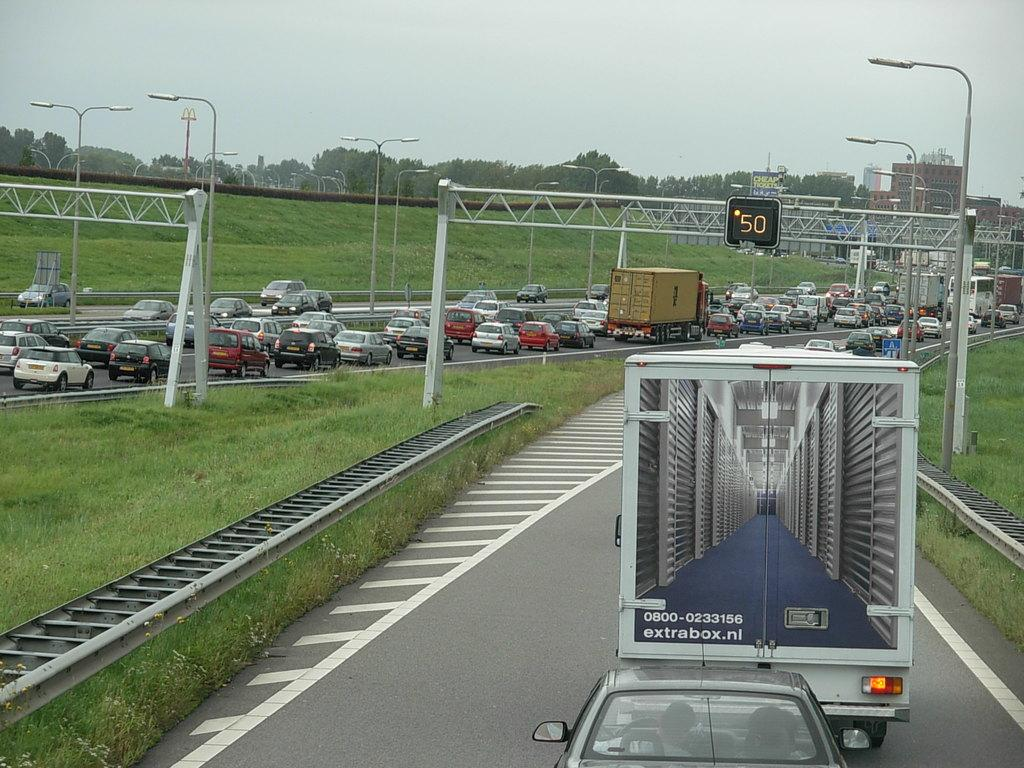What is happening on the road in the image? There are vehicles on the road in the image. What can be seen in the background of the image? In the background of the image, there are poles, metal rods, a digital screen, trees, and buildings. What type of vegetation is visible in the image? Grass is visible in the image. What time of day is it in the image, and how does the connection between the cars affect the morning? The time of day cannot be determined from the image, and there is no connection between the cars mentioned in the image. The concept of "morning" is not present in the image. 